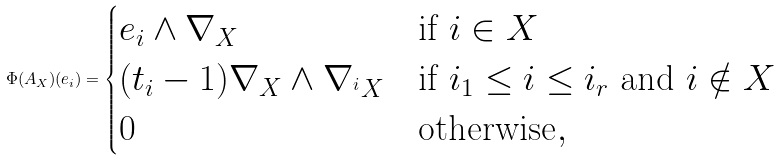<formula> <loc_0><loc_0><loc_500><loc_500>\Phi ( A _ { X } ) ( e _ { i } ) = \begin{cases} e _ { i } \wedge \nabla _ { X } & \text {if } i \in X \\ ( t _ { i } - 1 ) \nabla _ { X } \wedge \nabla _ { ^ { i } X } & \text {if } i _ { 1 } \leq i \leq i _ { r } \text { and } i \notin X \\ 0 & \text {otherwise} , \end{cases}</formula> 